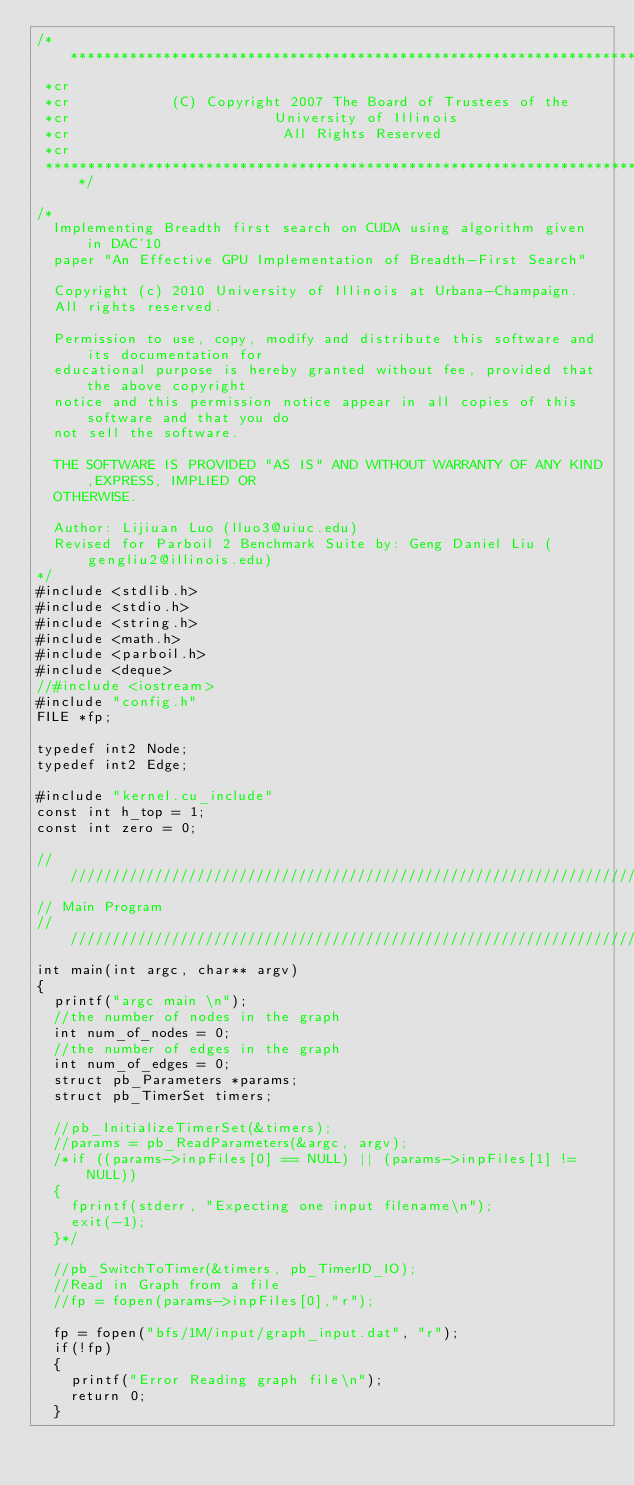<code> <loc_0><loc_0><loc_500><loc_500><_Cuda_>/***************************************************************************
 *cr
 *cr            (C) Copyright 2007 The Board of Trustees of the
 *cr                        University of Illinois
 *cr                         All Rights Reserved
 *cr
 ***************************************************************************/

/*
  Implementing Breadth first search on CUDA using algorithm given in DAC'10
  paper "An Effective GPU Implementation of Breadth-First Search"

  Copyright (c) 2010 University of Illinois at Urbana-Champaign. 
  All rights reserved.

  Permission to use, copy, modify and distribute this software and its documentation for 
  educational purpose is hereby granted without fee, provided that the above copyright 
  notice and this permission notice appear in all copies of this software and that you do 
  not sell the software.

  THE SOFTWARE IS PROVIDED "AS IS" AND WITHOUT WARRANTY OF ANY KIND,EXPRESS, IMPLIED OR 
  OTHERWISE.

  Author: Lijiuan Luo (lluo3@uiuc.edu)
  Revised for Parboil 2 Benchmark Suite by: Geng Daniel Liu (gengliu2@illinois.edu)
*/
#include <stdlib.h>
#include <stdio.h>
#include <string.h>
#include <math.h>
#include <parboil.h>
#include <deque>
//#include <iostream>
#include "config.h"
FILE *fp;

typedef int2 Node;
typedef int2 Edge;

#include "kernel.cu_include"
const int h_top = 1;
const int zero = 0;

////////////////////////////////////////////////////////////////////////////////
// Main Program
////////////////////////////////////////////////////////////////////////////////
int main(int argc, char** argv) 
{
  printf("argc main \n");
  //the number of nodes in the graph
  int num_of_nodes = 0; 
  //the number of edges in the graph
  int num_of_edges = 0;
  struct pb_Parameters *params;
  struct pb_TimerSet timers;

  //pb_InitializeTimerSet(&timers);
  //params = pb_ReadParameters(&argc, argv);
  /*if ((params->inpFiles[0] == NULL) || (params->inpFiles[1] != NULL))
  {
    fprintf(stderr, "Expecting one input filename\n");
    exit(-1);
  }*/

  //pb_SwitchToTimer(&timers, pb_TimerID_IO);
  //Read in Graph from a file
  //fp = fopen(params->inpFiles[0],"r");

  fp = fopen("bfs/1M/input/graph_input.dat", "r");
  if(!fp)
  {
    printf("Error Reading graph file\n");
    return 0;
  }</code> 